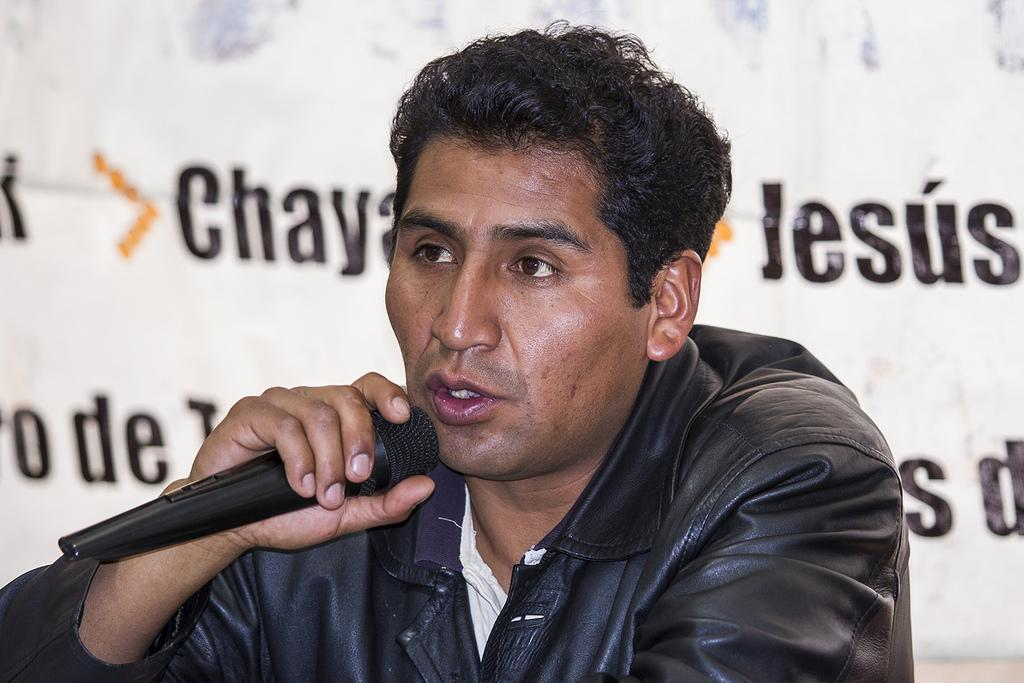What is present in the image? There is a person in the image. Can you describe the person's clothing? The person is wearing a black jacket. What object is the person holding in their left hand? The person is holding a microphone in their left hand. What type of beef is being served on a plate in the image? There is no beef present in the image. Is the person reading a book in the image? There is no book present in the image. What type of bag is the person carrying in the image? There is no bag present in the image. 